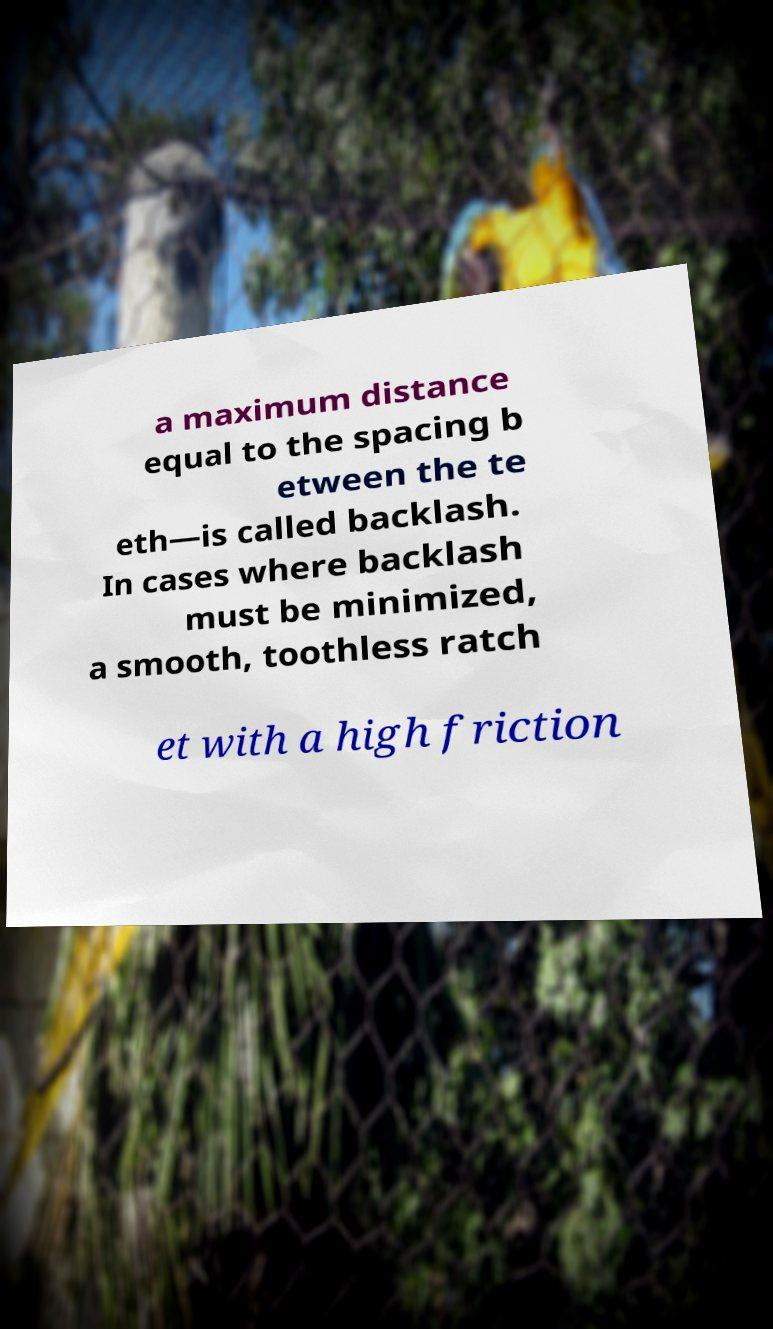Could you assist in decoding the text presented in this image and type it out clearly? a maximum distance equal to the spacing b etween the te eth—is called backlash. In cases where backlash must be minimized, a smooth, toothless ratch et with a high friction 